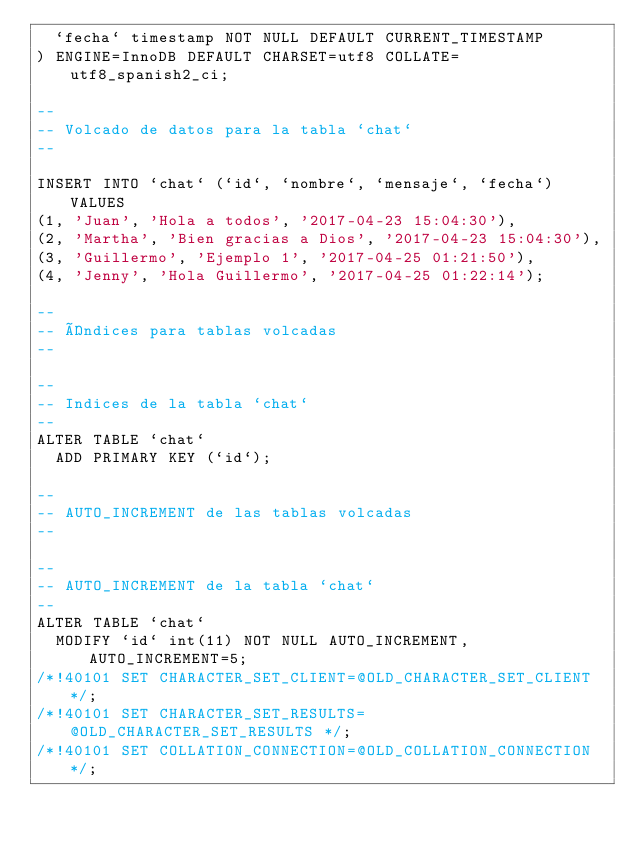<code> <loc_0><loc_0><loc_500><loc_500><_SQL_>  `fecha` timestamp NOT NULL DEFAULT CURRENT_TIMESTAMP
) ENGINE=InnoDB DEFAULT CHARSET=utf8 COLLATE=utf8_spanish2_ci;

--
-- Volcado de datos para la tabla `chat`
--

INSERT INTO `chat` (`id`, `nombre`, `mensaje`, `fecha`) VALUES
(1, 'Juan', 'Hola a todos', '2017-04-23 15:04:30'),
(2, 'Martha', 'Bien gracias a Dios', '2017-04-23 15:04:30'),
(3, 'Guillermo', 'Ejemplo 1', '2017-04-25 01:21:50'),
(4, 'Jenny', 'Hola Guillermo', '2017-04-25 01:22:14');

--
-- Índices para tablas volcadas
--

--
-- Indices de la tabla `chat`
--
ALTER TABLE `chat`
  ADD PRIMARY KEY (`id`);

--
-- AUTO_INCREMENT de las tablas volcadas
--

--
-- AUTO_INCREMENT de la tabla `chat`
--
ALTER TABLE `chat`
  MODIFY `id` int(11) NOT NULL AUTO_INCREMENT, AUTO_INCREMENT=5;
/*!40101 SET CHARACTER_SET_CLIENT=@OLD_CHARACTER_SET_CLIENT */;
/*!40101 SET CHARACTER_SET_RESULTS=@OLD_CHARACTER_SET_RESULTS */;
/*!40101 SET COLLATION_CONNECTION=@OLD_COLLATION_CONNECTION */;
</code> 